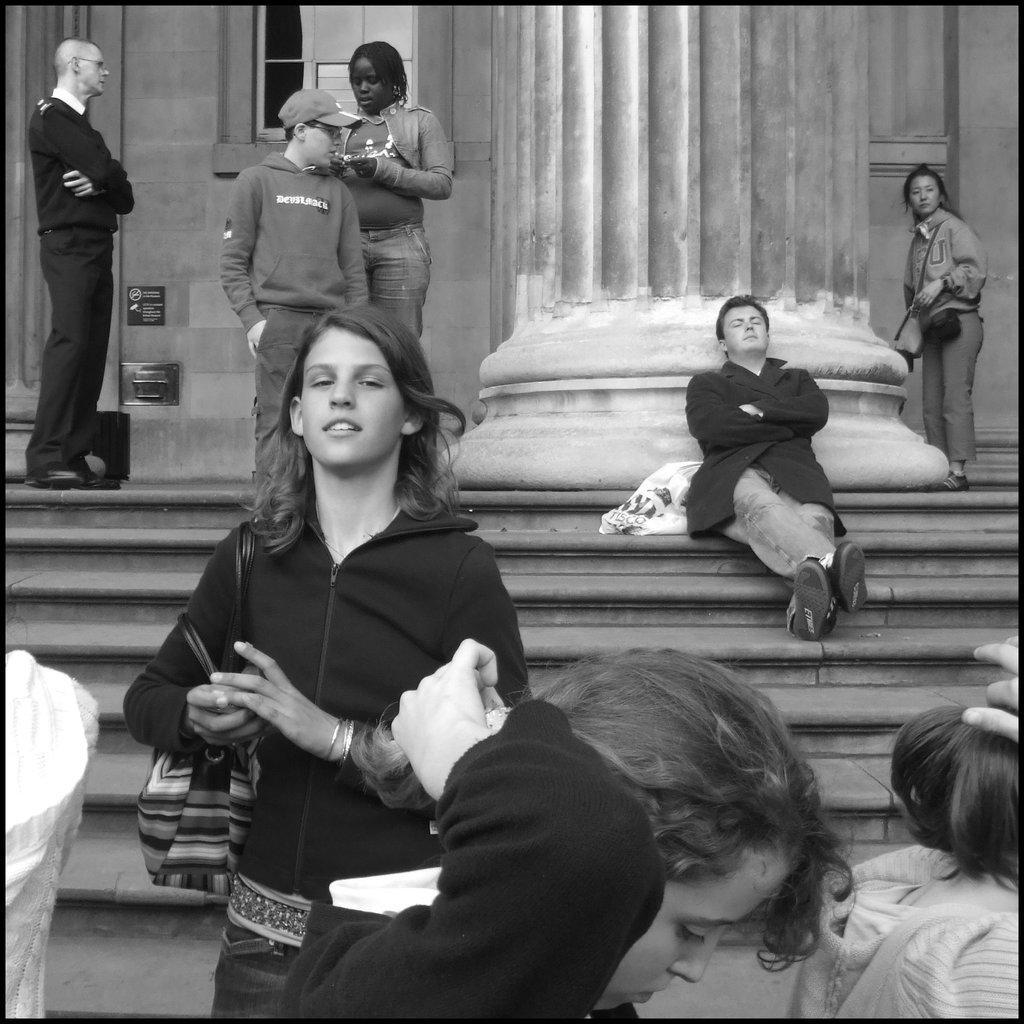Could you give a brief overview of what you see in this image? In this picture we can see some people standing here, there is a person sitting on a stair here, this girl is carrying a bag, in the background there is a wall, we can see a pillar here, this man wore a cap. 